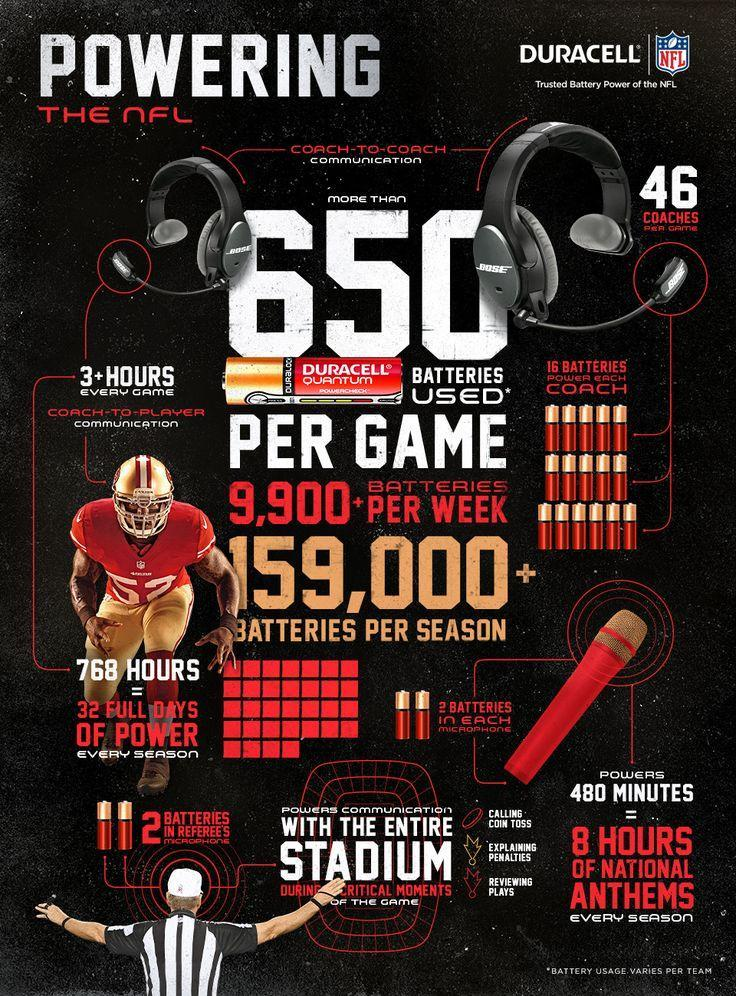How many batteries are required by each coach?
Answer the question with a short phrase. 16 For how much time does coach-to-player communication take place for each game? 3+ hours How many batteries are used in a microphone? 2 How many batteries can power 480 minutes on a microphone? 2 